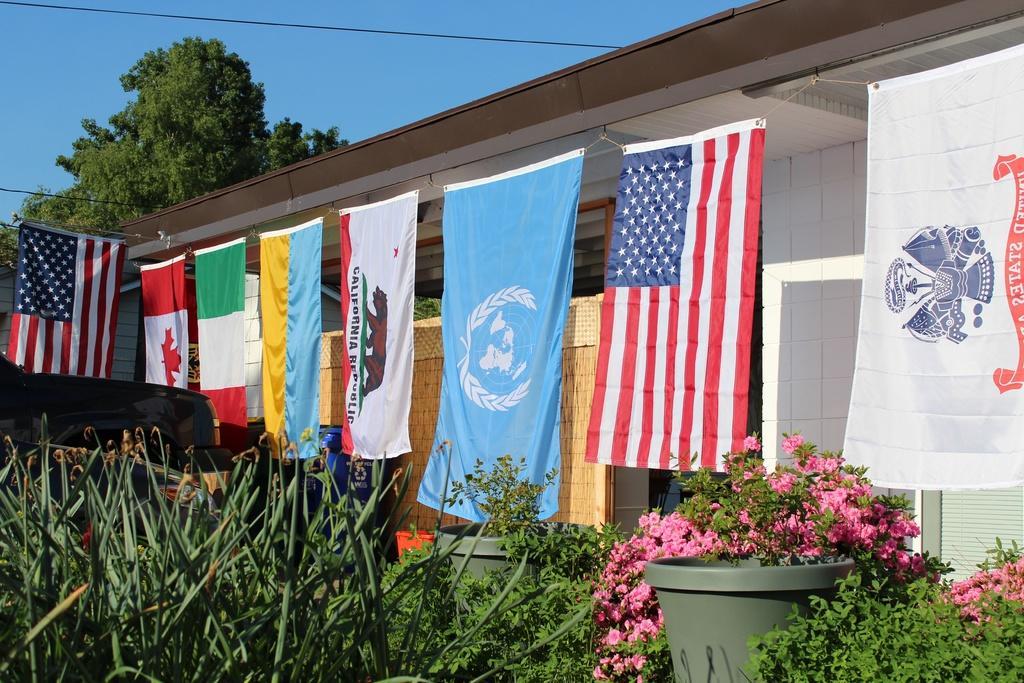In one or two sentences, can you explain what this image depicts? In this image there are plants , flowers, house, flags, tree ,and in the background there is sky. 